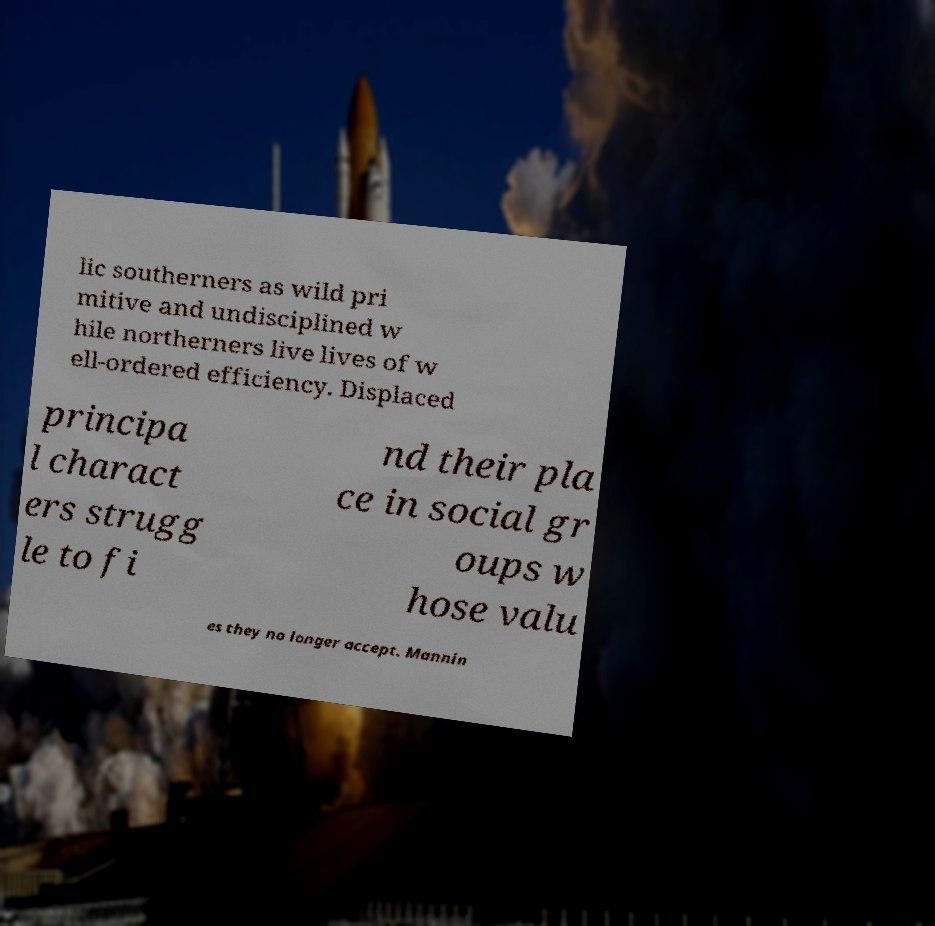Can you accurately transcribe the text from the provided image for me? lic southerners as wild pri mitive and undisciplined w hile northerners live lives of w ell-ordered efficiency. Displaced principa l charact ers strugg le to fi nd their pla ce in social gr oups w hose valu es they no longer accept. Mannin 